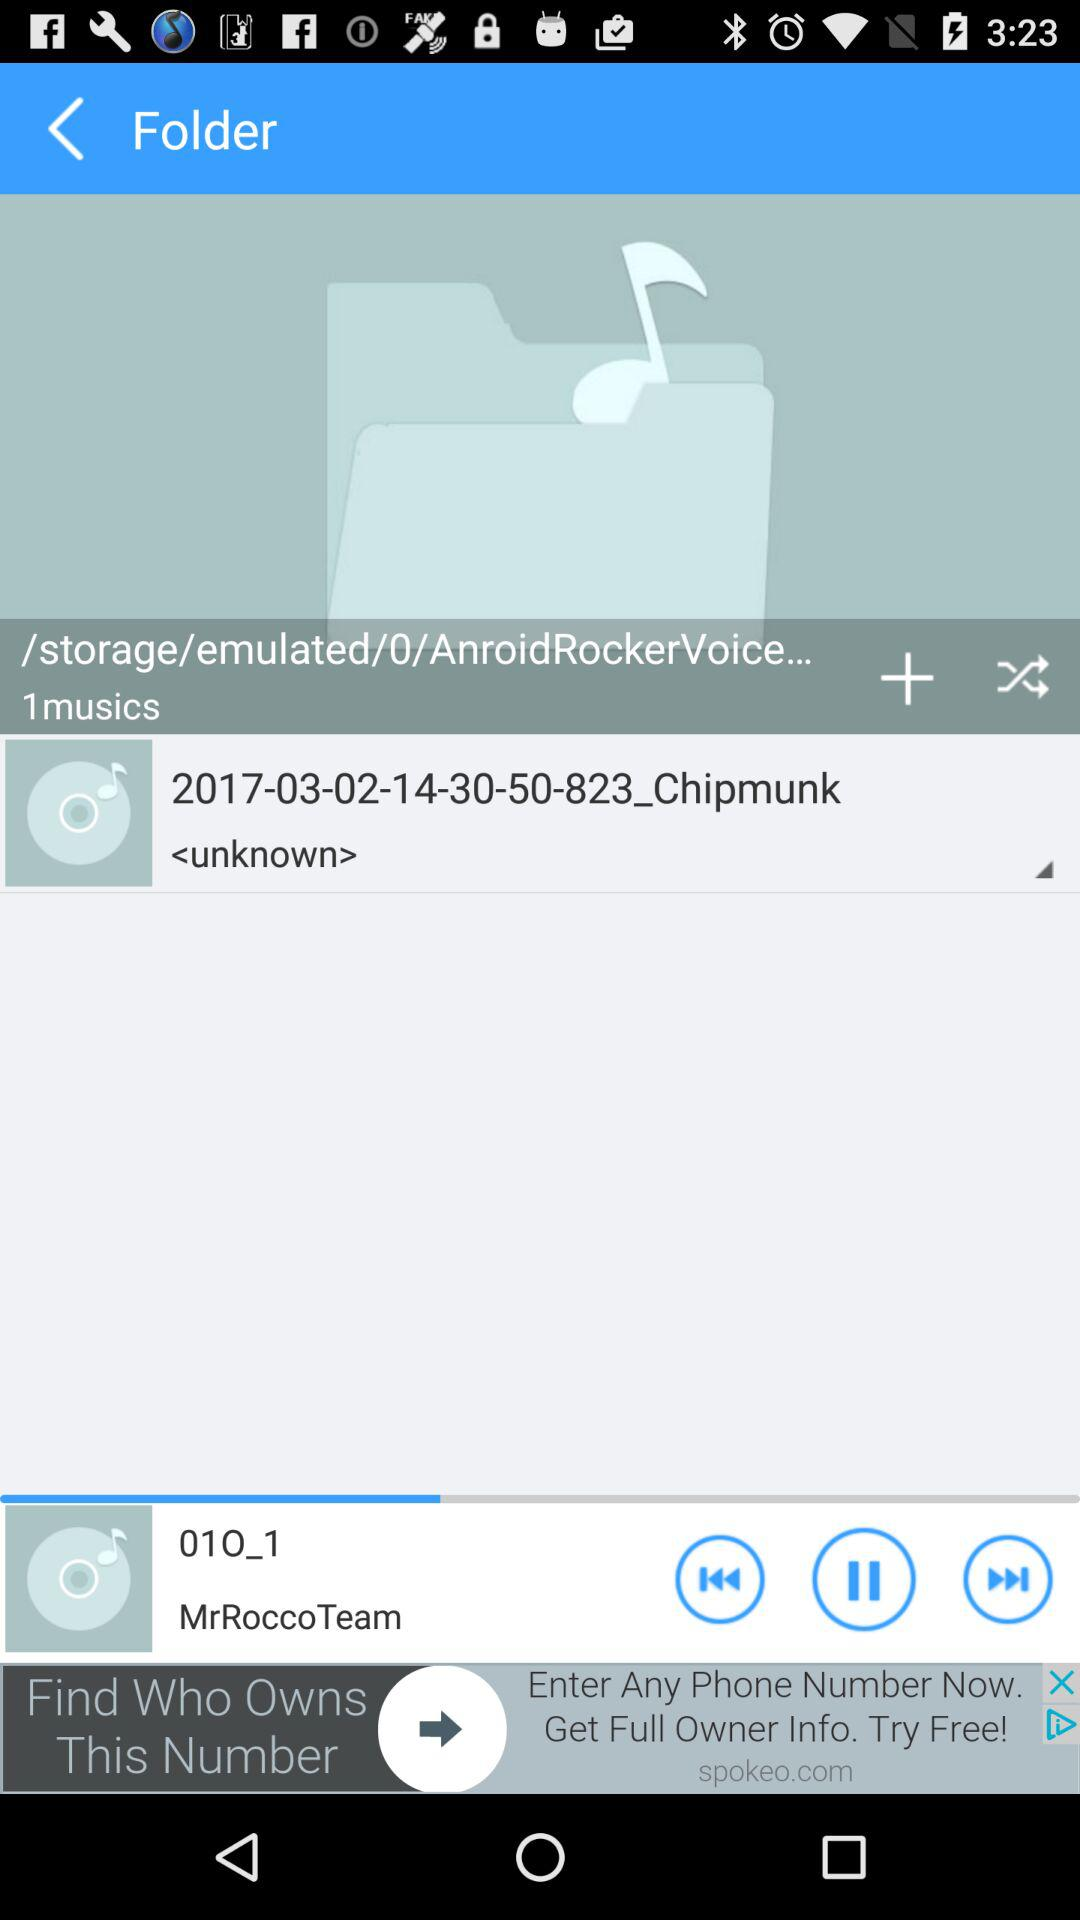Which song is currently playing? The song "01O_1" is currently playing. 